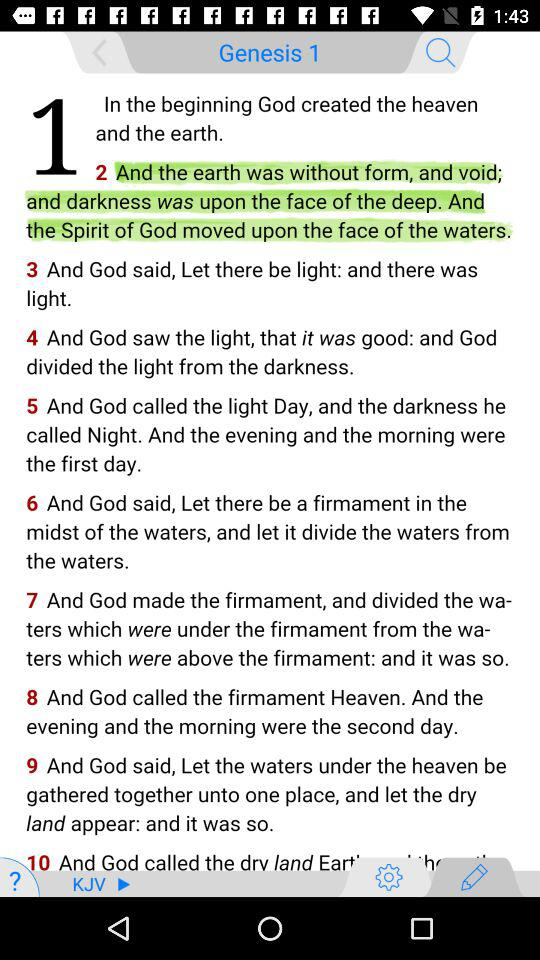How many verses are there in the first chapter of Genesis?
Answer the question using a single word or phrase. 10 